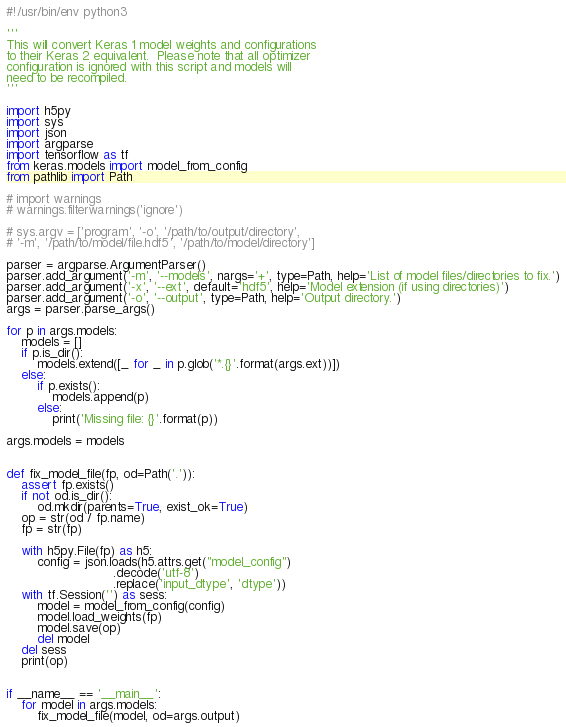Convert code to text. <code><loc_0><loc_0><loc_500><loc_500><_Python_>#!/usr/bin/env python3

'''
This will convert Keras 1 model weights and configurations
to their Keras 2 equivalent.  Please note that all optimizer
configuration is ignored with this script and models will
need to be recompiled.
'''

import h5py
import sys
import json
import argparse
import tensorflow as tf
from keras.models import model_from_config
from pathlib import Path

# import warnings
# warnings.filterwarnings('ignore')

# sys.argv = ['program', '-o', '/path/to/output/directory',
# '-m', '/path/to/model/file.hdf5', '/path/to/model/directory']

parser = argparse.ArgumentParser()
parser.add_argument('-m', '--models', nargs='+', type=Path, help='List of model files/directories to fix.')
parser.add_argument('-x', '--ext', default='hdf5', help='Model extension (if using directories)')
parser.add_argument('-o', '--output', type=Path, help='Output directory.')
args = parser.parse_args()

for p in args.models:
    models = []
    if p.is_dir():
        models.extend([_ for _ in p.glob('*.{}'.format(args.ext))])
    else:
        if p.exists():
            models.append(p)
        else:
            print('Missing file: {}'.format(p))

args.models = models


def fix_model_file(fp, od=Path('.')):
    assert fp.exists()
    if not od.is_dir():
        od.mkdir(parents=True, exist_ok=True)
    op = str(od / fp.name)
    fp = str(fp)

    with h5py.File(fp) as h5:
        config = json.loads(h5.attrs.get("model_config")
                            .decode('utf-8')
                            .replace('input_dtype', 'dtype'))
    with tf.Session('') as sess:
        model = model_from_config(config)
        model.load_weights(fp)
        model.save(op)
        del model
    del sess
    print(op)


if __name__ == '__main__':
    for model in args.models:
        fix_model_file(model, od=args.output)</code> 